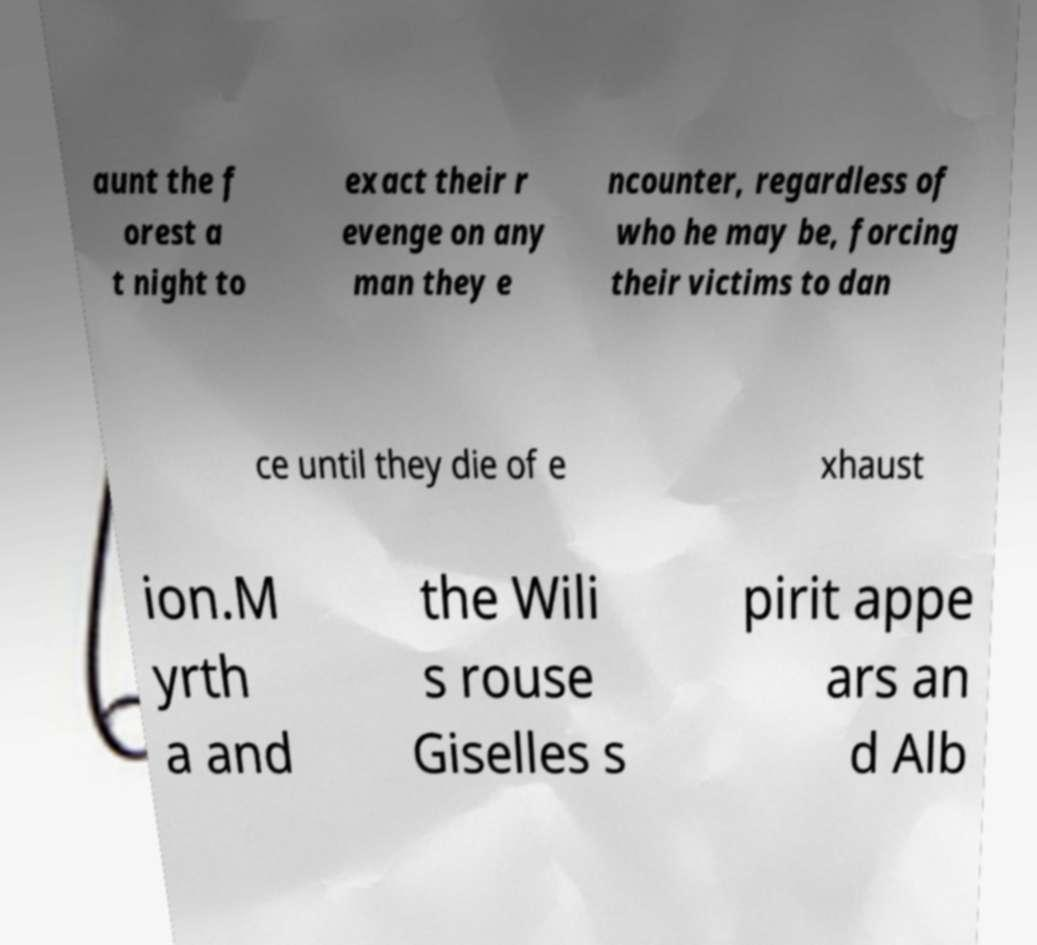Can you read and provide the text displayed in the image?This photo seems to have some interesting text. Can you extract and type it out for me? aunt the f orest a t night to exact their r evenge on any man they e ncounter, regardless of who he may be, forcing their victims to dan ce until they die of e xhaust ion.M yrth a and the Wili s rouse Giselles s pirit appe ars an d Alb 